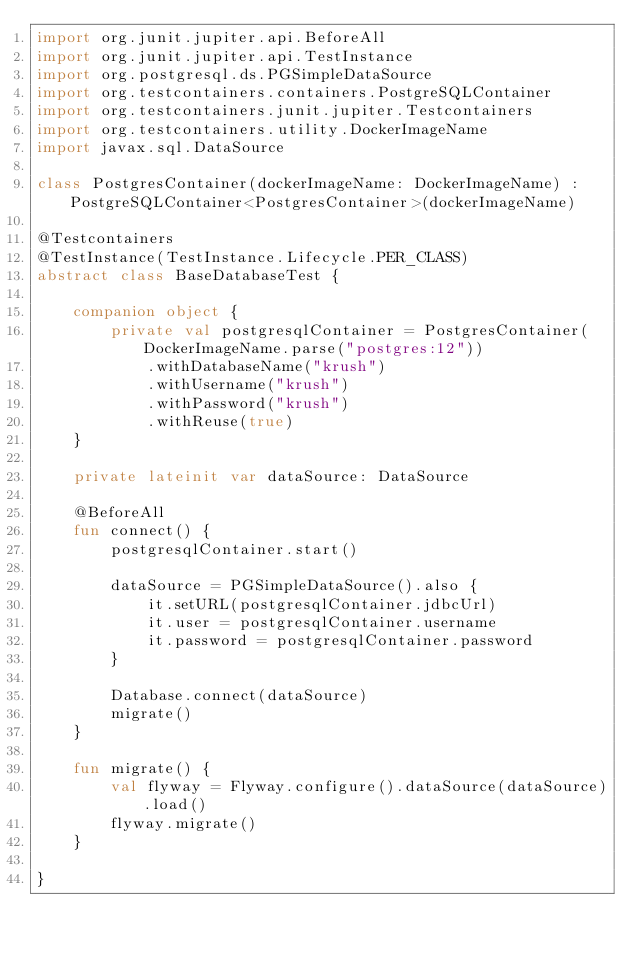<code> <loc_0><loc_0><loc_500><loc_500><_Kotlin_>import org.junit.jupiter.api.BeforeAll
import org.junit.jupiter.api.TestInstance
import org.postgresql.ds.PGSimpleDataSource
import org.testcontainers.containers.PostgreSQLContainer
import org.testcontainers.junit.jupiter.Testcontainers
import org.testcontainers.utility.DockerImageName
import javax.sql.DataSource

class PostgresContainer(dockerImageName: DockerImageName) : PostgreSQLContainer<PostgresContainer>(dockerImageName)

@Testcontainers
@TestInstance(TestInstance.Lifecycle.PER_CLASS)
abstract class BaseDatabaseTest {

    companion object {
        private val postgresqlContainer = PostgresContainer(DockerImageName.parse("postgres:12"))
            .withDatabaseName("krush")
            .withUsername("krush")
            .withPassword("krush")
            .withReuse(true)
    }

    private lateinit var dataSource: DataSource

    @BeforeAll
    fun connect() {
        postgresqlContainer.start()

        dataSource = PGSimpleDataSource().also {
            it.setURL(postgresqlContainer.jdbcUrl)
            it.user = postgresqlContainer.username
            it.password = postgresqlContainer.password
        }

        Database.connect(dataSource)
        migrate()
    }

    fun migrate() {
        val flyway = Flyway.configure().dataSource(dataSource).load()
        flyway.migrate()
    }

}
</code> 